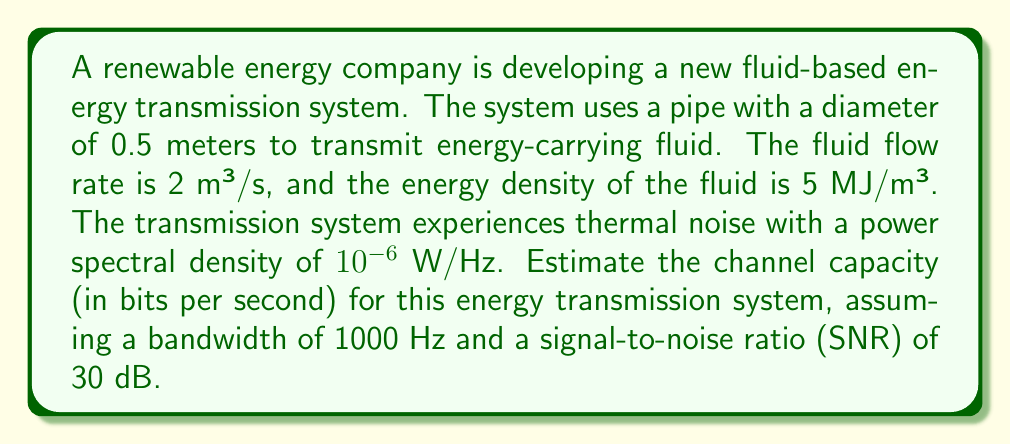Could you help me with this problem? To estimate the channel capacity for this energy transmission system, we'll use the Shannon-Hartley theorem, which relates channel capacity to bandwidth and signal-to-noise ratio. Here's a step-by-step approach:

1. Calculate the signal power:
   The signal power is the rate of energy transmission.
   Energy transmission rate = Flow rate × Energy density
   $$P_s = 2 \text{ m³/s} \times 5 \text{ MJ/m³} = 10 \text{ MW} = 10^7 \text{ W}$$

2. Calculate the noise power:
   Noise power = Noise power spectral density × Bandwidth
   $$P_n = 10^{-6} \text{ W/Hz} \times 1000 \text{ Hz} = 10^{-3} \text{ W}$$

3. Convert the given SNR from dB to a linear ratio:
   $$\text{SNR}_{\text{linear}} = 10^{\frac{\text{SNR}_{\text{dB}}}{10}} = 10^{\frac{30}{10}} = 1000$$

4. Verify if the calculated SNR matches the given SNR:
   $$\text{SNR}_{\text{calculated}} = \frac{P_s}{P_n} = \frac{10^7}{10^{-3}} = 10^{10}$$
   This is much higher than the given SNR, so we'll use the given SNR for our calculation.

5. Apply the Shannon-Hartley theorem to calculate the channel capacity:
   $$C = B \log_2(1 + \text{SNR})$$
   Where:
   C = Channel capacity (bits/s)
   B = Bandwidth (Hz)
   SNR = Signal-to-noise ratio (linear)

   $$C = 1000 \times \log_2(1 + 1000)$$
   $$C = 1000 \times \log_2(1001)$$
   $$C = 1000 \times 9.97$$
   $$C \approx 9970 \text{ bits/s}$$
Answer: The estimated channel capacity for the energy transmission system is approximately 9970 bits per second. 